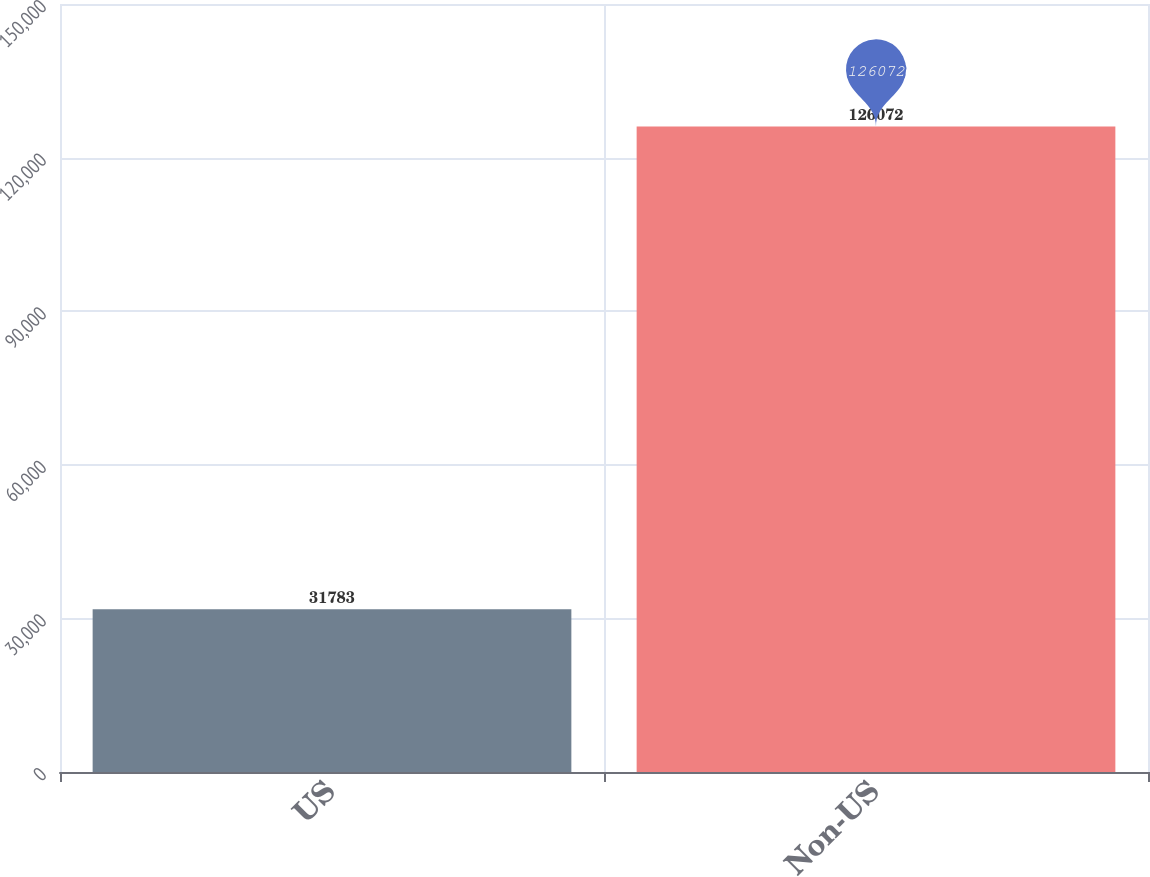Convert chart. <chart><loc_0><loc_0><loc_500><loc_500><bar_chart><fcel>US<fcel>Non-US<nl><fcel>31783<fcel>126072<nl></chart> 